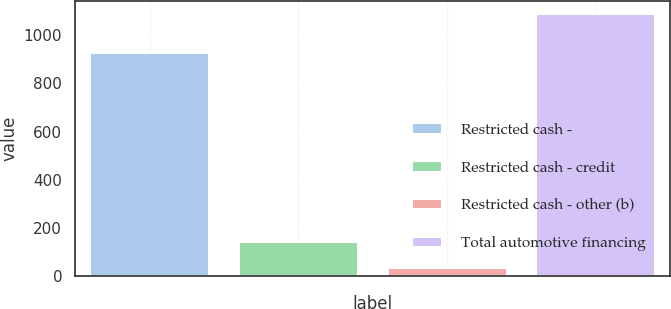Convert chart to OTSL. <chart><loc_0><loc_0><loc_500><loc_500><bar_chart><fcel>Restricted cash -<fcel>Restricted cash - credit<fcel>Restricted cash - other (b)<fcel>Total automotive financing<nl><fcel>926<fcel>138.7<fcel>33<fcel>1090<nl></chart> 